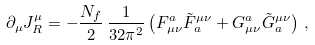<formula> <loc_0><loc_0><loc_500><loc_500>\partial _ { \mu } J ^ { \mu } _ { R } = - \frac { N _ { f } } { 2 } \, \frac { 1 } { 3 2 \pi ^ { 2 } } \left ( F _ { \mu \nu } ^ { a } \tilde { F } _ { a } ^ { \mu \nu } + G _ { \mu \nu } ^ { a } \tilde { G } _ { a } ^ { \mu \nu } \right ) \, ,</formula> 